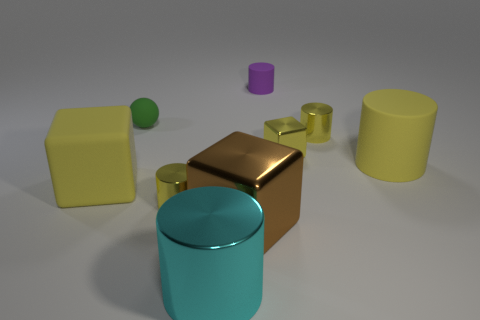Subtract all gray blocks. How many yellow cylinders are left? 3 Subtract all blue cylinders. Subtract all red spheres. How many cylinders are left? 5 Add 1 blue cylinders. How many objects exist? 10 Subtract all balls. How many objects are left? 8 Subtract all green matte blocks. Subtract all big yellow cylinders. How many objects are left? 8 Add 6 big metallic cubes. How many big metallic cubes are left? 7 Add 6 tiny shiny things. How many tiny shiny things exist? 9 Subtract 0 red cylinders. How many objects are left? 9 